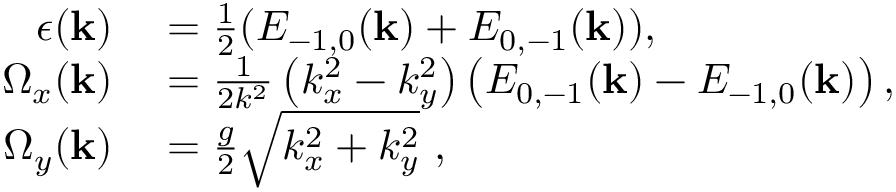Convert formula to latex. <formula><loc_0><loc_0><loc_500><loc_500>\begin{array} { r l } { \epsilon ( k ) } & = \frac { 1 } { 2 } ( E _ { - 1 , 0 } ( k ) + E _ { 0 , - 1 } ( k ) ) , } \\ { \Omega _ { x } ( k ) } & = \frac { 1 } { 2 k ^ { 2 } } \left ( k _ { x } ^ { 2 } - k _ { y } ^ { 2 } \right ) \left ( E _ { 0 , - 1 } ( k ) - E _ { - 1 , 0 } ( k ) \right ) , } \\ { \Omega _ { y } ( k ) } & = \frac { g } { 2 } \sqrt { k _ { x } ^ { 2 } + k _ { y } ^ { 2 } } , } \end{array}</formula> 